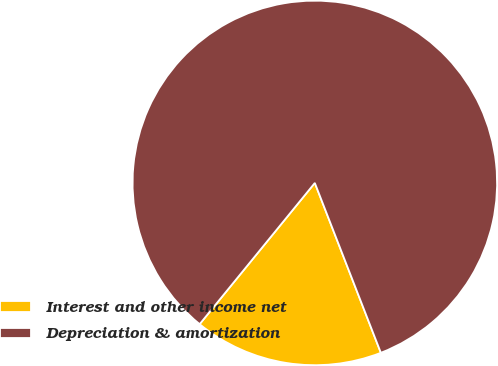<chart> <loc_0><loc_0><loc_500><loc_500><pie_chart><fcel>Interest and other income net<fcel>Depreciation & amortization<nl><fcel>16.79%<fcel>83.21%<nl></chart> 